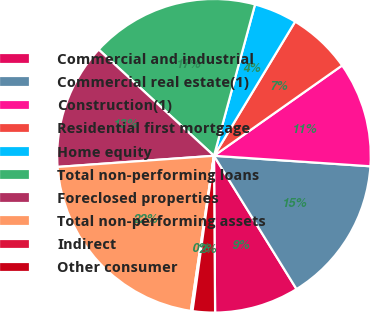<chart> <loc_0><loc_0><loc_500><loc_500><pie_chart><fcel>Commercial and industrial<fcel>Commercial real estate(1)<fcel>Construction(1)<fcel>Residential first mortgage<fcel>Home equity<fcel>Total non-performing loans<fcel>Foreclosed properties<fcel>Total non-performing assets<fcel>Indirect<fcel>Other consumer<nl><fcel>8.71%<fcel>15.11%<fcel>10.84%<fcel>6.57%<fcel>4.44%<fcel>17.37%<fcel>12.98%<fcel>21.51%<fcel>0.17%<fcel>2.3%<nl></chart> 